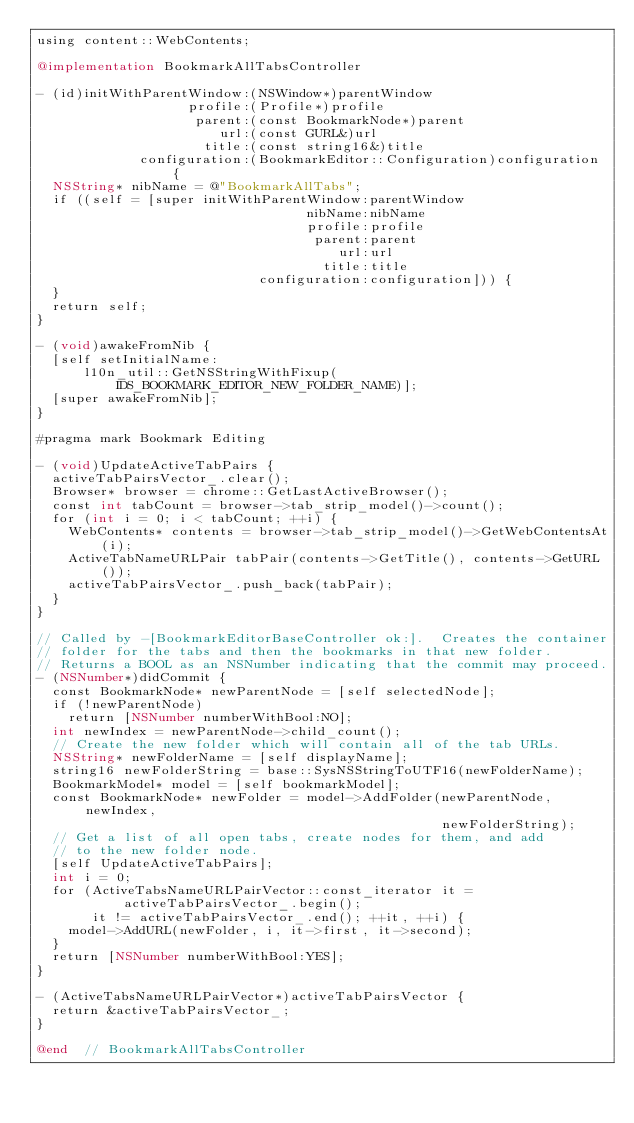Convert code to text. <code><loc_0><loc_0><loc_500><loc_500><_ObjectiveC_>using content::WebContents;

@implementation BookmarkAllTabsController

- (id)initWithParentWindow:(NSWindow*)parentWindow
                   profile:(Profile*)profile
                    parent:(const BookmarkNode*)parent
                       url:(const GURL&)url
                     title:(const string16&)title
             configuration:(BookmarkEditor::Configuration)configuration {
  NSString* nibName = @"BookmarkAllTabs";
  if ((self = [super initWithParentWindow:parentWindow
                                  nibName:nibName
                                  profile:profile
                                   parent:parent
                                      url:url
                                    title:title
                            configuration:configuration])) {
  }
  return self;
}

- (void)awakeFromNib {
  [self setInitialName:
      l10n_util::GetNSStringWithFixup(IDS_BOOKMARK_EDITOR_NEW_FOLDER_NAME)];
  [super awakeFromNib];
}

#pragma mark Bookmark Editing

- (void)UpdateActiveTabPairs {
  activeTabPairsVector_.clear();
  Browser* browser = chrome::GetLastActiveBrowser();
  const int tabCount = browser->tab_strip_model()->count();
  for (int i = 0; i < tabCount; ++i) {
    WebContents* contents = browser->tab_strip_model()->GetWebContentsAt(i);
    ActiveTabNameURLPair tabPair(contents->GetTitle(), contents->GetURL());
    activeTabPairsVector_.push_back(tabPair);
  }
}

// Called by -[BookmarkEditorBaseController ok:].  Creates the container
// folder for the tabs and then the bookmarks in that new folder.
// Returns a BOOL as an NSNumber indicating that the commit may proceed.
- (NSNumber*)didCommit {
  const BookmarkNode* newParentNode = [self selectedNode];
  if (!newParentNode)
    return [NSNumber numberWithBool:NO];
  int newIndex = newParentNode->child_count();
  // Create the new folder which will contain all of the tab URLs.
  NSString* newFolderName = [self displayName];
  string16 newFolderString = base::SysNSStringToUTF16(newFolderName);
  BookmarkModel* model = [self bookmarkModel];
  const BookmarkNode* newFolder = model->AddFolder(newParentNode, newIndex,
                                                   newFolderString);
  // Get a list of all open tabs, create nodes for them, and add
  // to the new folder node.
  [self UpdateActiveTabPairs];
  int i = 0;
  for (ActiveTabsNameURLPairVector::const_iterator it =
           activeTabPairsVector_.begin();
       it != activeTabPairsVector_.end(); ++it, ++i) {
    model->AddURL(newFolder, i, it->first, it->second);
  }
  return [NSNumber numberWithBool:YES];
}

- (ActiveTabsNameURLPairVector*)activeTabPairsVector {
  return &activeTabPairsVector_;
}

@end  // BookmarkAllTabsController

</code> 